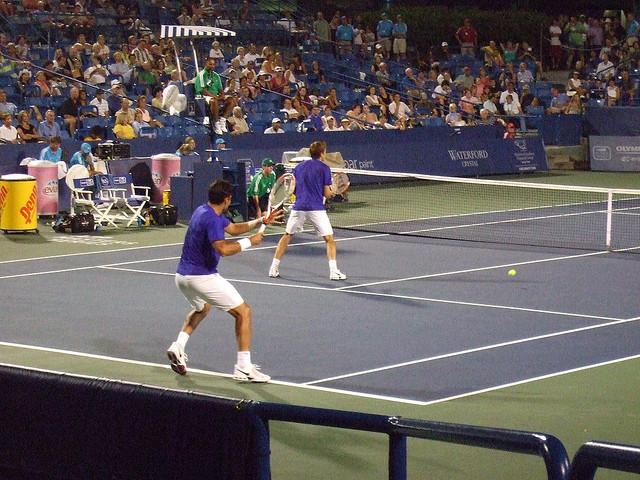Are they playing tennis?
Give a very brief answer. Yes. What are the 3 containers on the left side?
Keep it brief. Beverages. What color is the court?
Give a very brief answer. Blue. Did he hit the ball?
Quick response, please. Yes. Which player's feet are both flat on the ground?
Keep it brief. Front. What are they doing with their hands?
Quick response, please. Holding rackets. Is this match a doubles match?
Write a very short answer. Yes. How many chairs are there?
Concise answer only. 2. Is this a team sport or an individual sport?
Answer briefly. Team. 